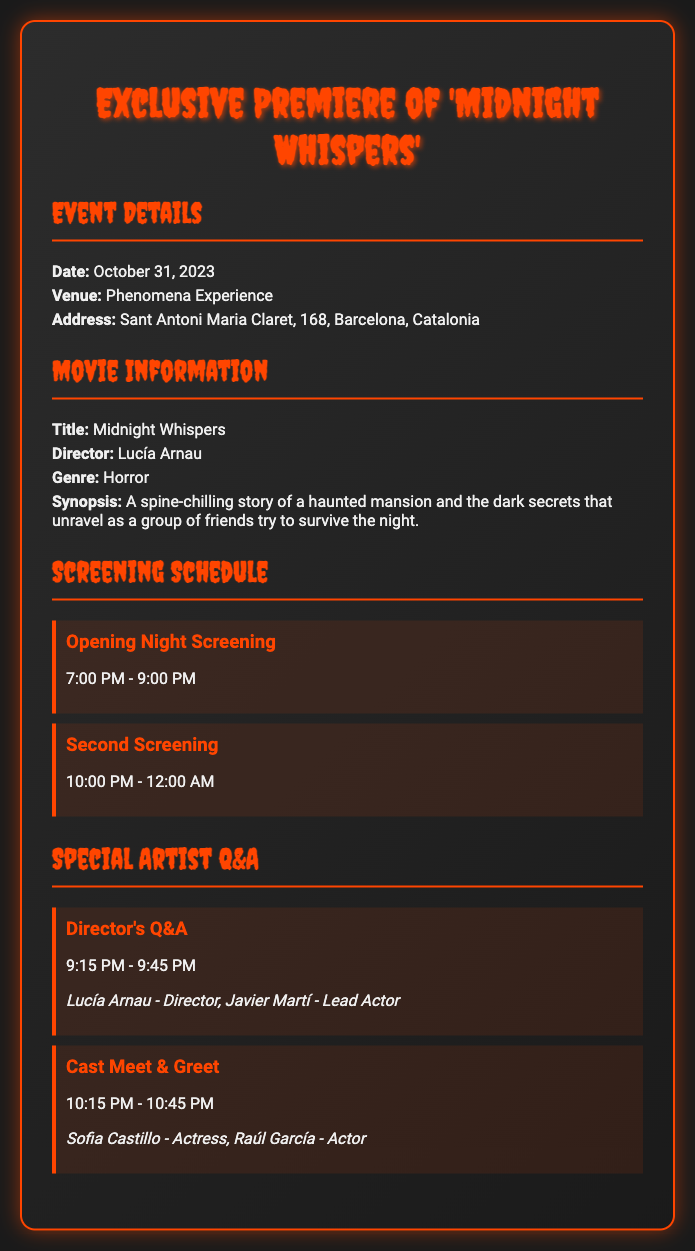what is the date of the event? The date of the event is explicitly provided in the document as October 31, 2023.
Answer: October 31, 2023 where is the venue located? The venue is stated in the ticket document, which is Phenomena Experience, situated at Sant Antoni Maria Claret, 168, Barcelona, Catalonia.
Answer: Phenomena Experience who is the director of the movie? The document mentions the director of the movie "Midnight Whispers" as Lucía Arnau.
Answer: Lucía Arnau what time does the second screening start? According to the document, the second screening time starts at 10:00 PM.
Answer: 10:00 PM how long is the Director's Q&A session? The duration of the Director's Q&A session can be deduced by the start and end times provided in the document, from 9:15 PM to 9:45 PM, giving it a duration of 30 minutes.
Answer: 30 minutes what is the genre of the movie? The genre of the movie mentioned in the document is horror.
Answer: Horror who are the participants in the Director's Q&A session? The participants in the Director's Q&A session are specified as Lucía Arnau and Javier Martí in the document.
Answer: Lucía Arnau - Director, Javier Martí - Lead Actor when does the Cast Meet & Greet begin? The document states the start time for the Cast Meet & Greet is at 10:15 PM.
Answer: 10:15 PM what is the title of the movie being premiered? The title of the movie being premiered is clearly indicated in the document as "Midnight Whispers."
Answer: Midnight Whispers 